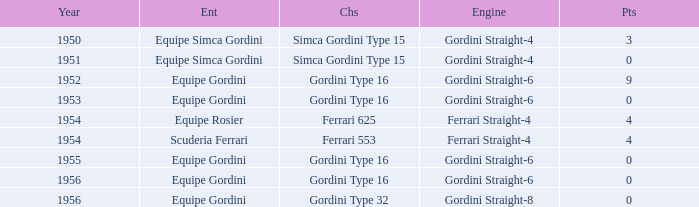Before 1956, what Chassis has Gordini Straight-4 engine with 3 points? Simca Gordini Type 15. 